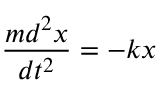Convert formula to latex. <formula><loc_0><loc_0><loc_500><loc_500>\frac { m d ^ { 2 } x } { d t ^ { 2 } } = - k x</formula> 